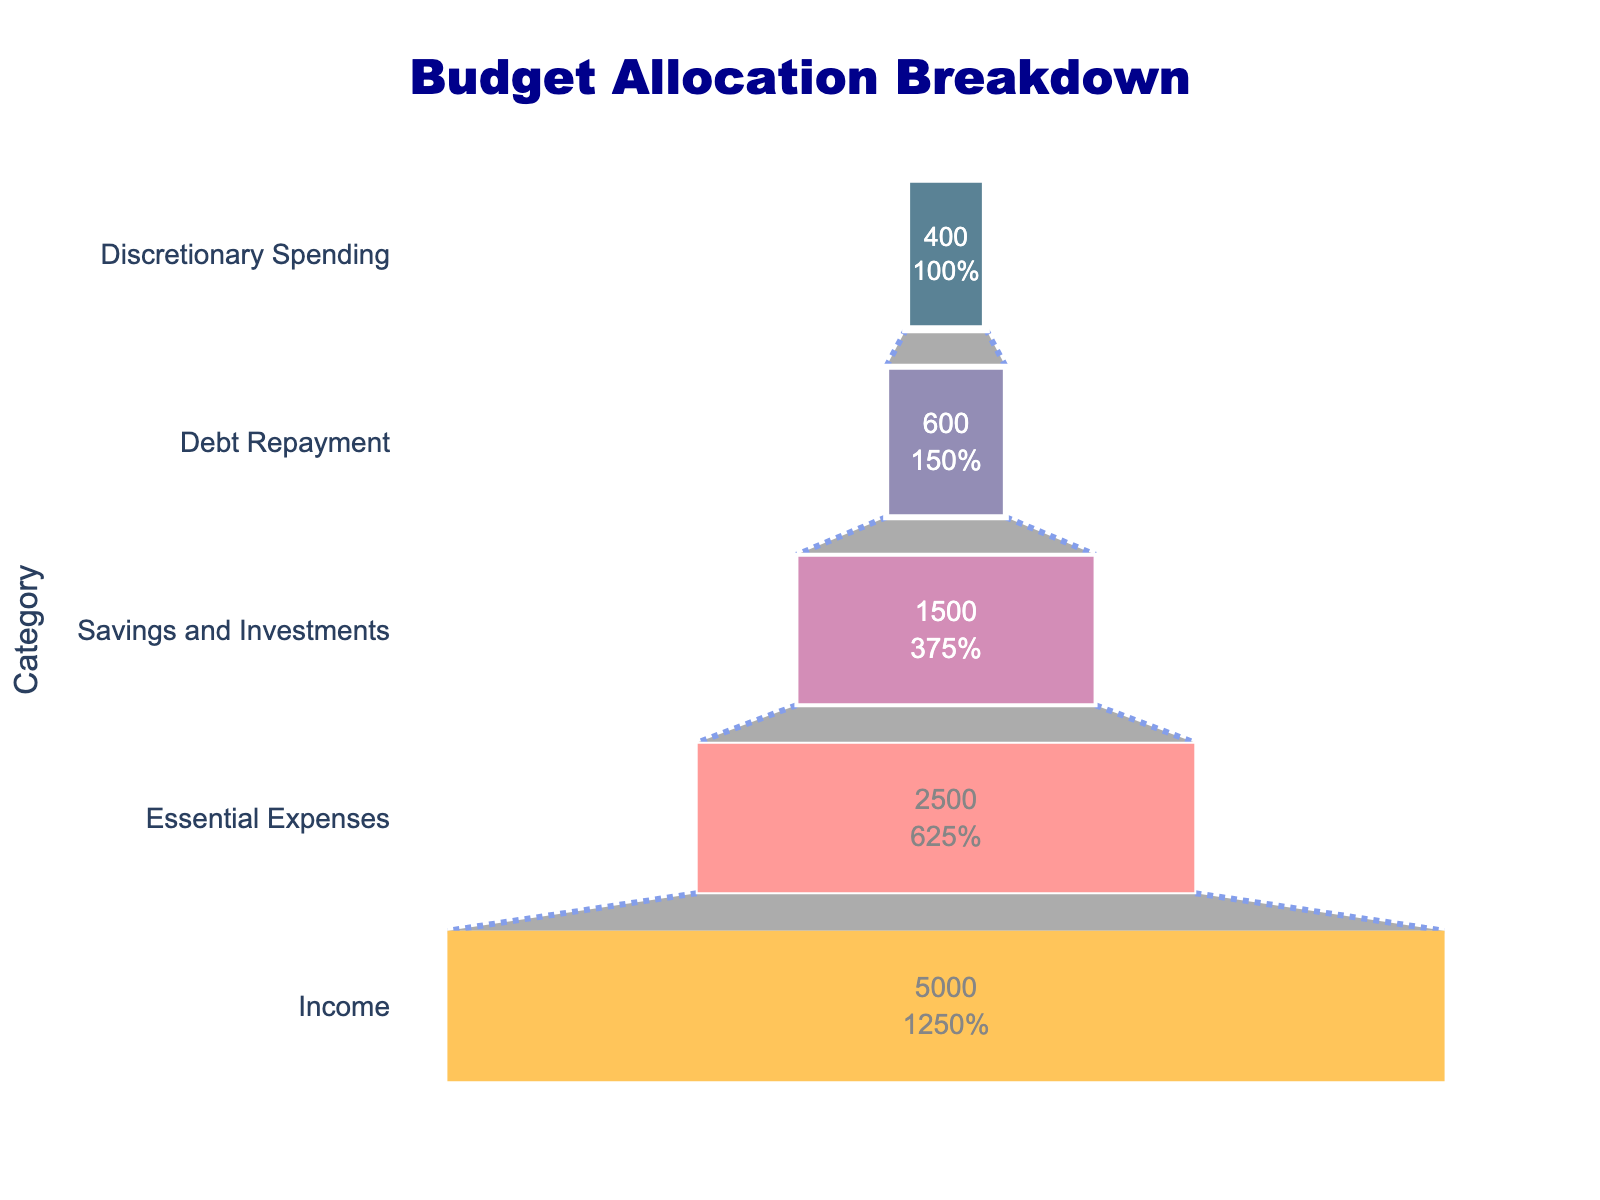What is the title of the chart? The title is usually written at the top of the chart. It gives a summary of the chart's content. Here, the title "Budget Allocation Breakdown" is displayed prominently at the top.
Answer: Budget Allocation Breakdown How much is allocated for Essential Expenses? To find the amount allocated for Essential Expenses, look at the corresponding bar in the funnel chart. It shows an amount of $2,500 for Essential Expenses.
Answer: $2,500 Compare the amounts allocated to Debt Repayment and Discretionary Spending. Which is higher? By looking at the lengths of the bars or the values inside them, you can compare. Debt Repayment has $600, whereas Discretionary Spending has $400. Debt Repayment being higher is evident.
Answer: Debt Repayment What percentage of the Income is allocated to Savings and Investments? The funnel chart typically shows percentages of the initial value on the bars. For Savings and Investments, identify its percentage of the total Income ($5,000). The label inside the bar shows 30%.
Answer: 30% What is the smallest amount allocated, and which category does it belong to? To find the smallest amount, look at the shortest bar or the smallest value among the categories. The smallest value is $400, belonging to Discretionary Spending.
Answer: Discretionary Spending How much more is allocated to Essential Expenses than Discretionary Spending? To find the difference, subtract the amount for Discretionary Spending ($400) from Essential Expenses ($2,500). So, $2,500 - $400 = $2,100.
Answer: $2,100 What's the total amount allocated to Savings and Investments, Debt Repayment, and Discretionary Spending? Add the amounts for these categories: Savings and Investments ($1,500), Debt Repayment ($600), and Discretionary Spending ($400). The total is $1,500 + $600 + $400 = $2,500.
Answer: $2,500 Is the amount allocated for Savings and Investments greater than half of the Income? To determine this, find half of the Income ($5,000 / 2 = $2,500) and compare it to the amount for Savings and Investments ($1,500). Since $1,500 is less than $2,500, it is not greater than half.
Answer: No Which category has the largest allocation, and how much is it? Identify the category with the longest bar or the highest value. The largest allocation is for Income, which amounts to $5,000.
Answer: Income, $5,000 If the allocation for Debt Repayment was increased by 50%, what would the new amount be? Calculate 50% of the current Debt Repayment amount ($600). This is $600 * 0.5 = $300. Add this to the original amount ($600 + $300 = $900).
Answer: $900 